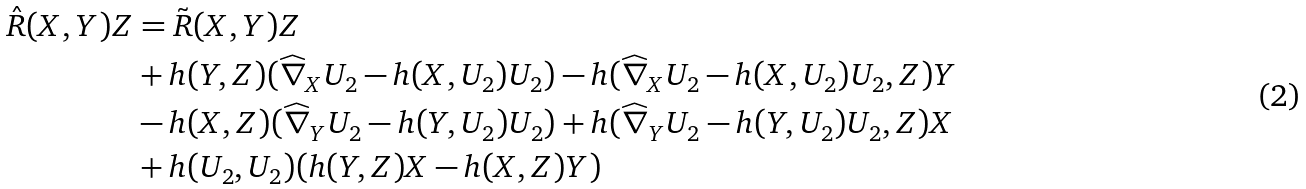Convert formula to latex. <formula><loc_0><loc_0><loc_500><loc_500>\hat { R } ( X , Y ) Z & = \tilde { R } ( X , Y ) Z \\ & + h ( Y , Z ) ( \widehat { \nabla } _ { X } U _ { 2 } - h ( X , U _ { 2 } ) U _ { 2 } ) - h ( \widehat { \nabla } _ { X } U _ { 2 } - h ( X , U _ { 2 } ) U _ { 2 } , Z ) Y \\ & - h ( X , Z ) ( \widehat { \nabla } _ { Y } U _ { 2 } - h ( Y , U _ { 2 } ) U _ { 2 } ) + h ( \widehat { \nabla } _ { Y } U _ { 2 } - h ( Y , U _ { 2 } ) U _ { 2 } , Z ) X \\ & + h ( U _ { 2 } , U _ { 2 } ) ( h ( Y , Z ) X - h ( X , Z ) Y )</formula> 